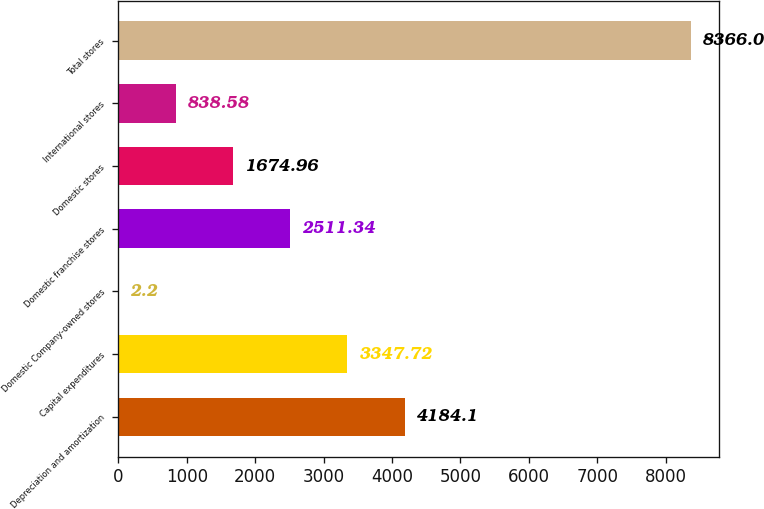<chart> <loc_0><loc_0><loc_500><loc_500><bar_chart><fcel>Depreciation and amortization<fcel>Capital expenditures<fcel>Domestic Company-owned stores<fcel>Domestic franchise stores<fcel>Domestic stores<fcel>International stores<fcel>Total stores<nl><fcel>4184.1<fcel>3347.72<fcel>2.2<fcel>2511.34<fcel>1674.96<fcel>838.58<fcel>8366<nl></chart> 